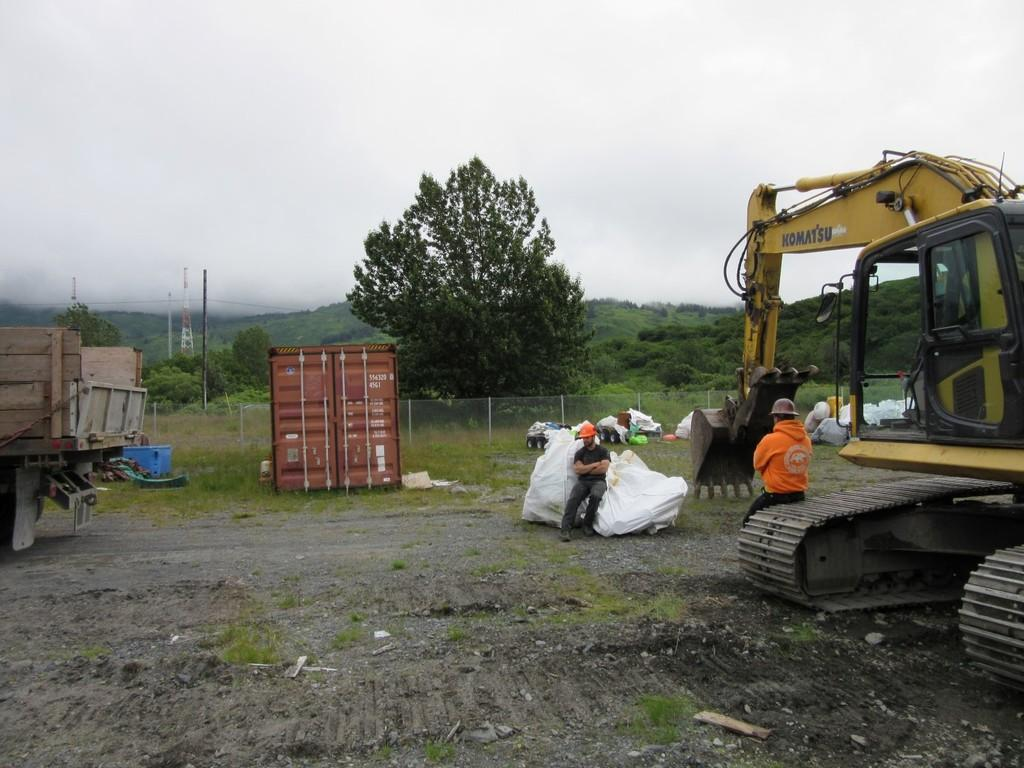Provide a one-sentence caption for the provided image. a man sitting on the belt of a Komatsu machine. 